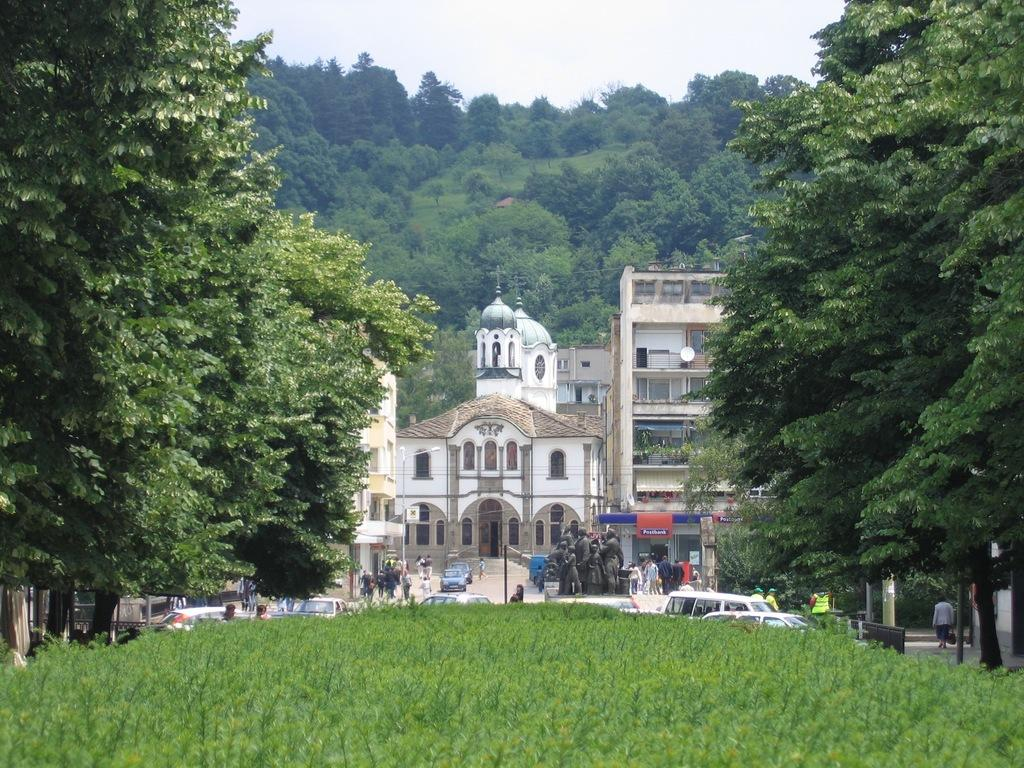What type of living organisms can be seen in the image? Plants and trees are visible in the image. What can be seen on the path in the image? There are vehicles on a path in the image. What type of gathering can be observed in the image? There are groups of people in the image. What structures are visible behind the people in the image? There are buildings behind the people in the image. What additional features are present in the image? There are statues in the image. What type of natural feature is present in the image? There is a hill in the image. What is visible in the sky in the image? The sky is visible in the image. What is the value of the sun in the image? There is no mention of the sun in the image, and therefore no value can be assigned to it. What type of army is present in the image? There is no army present in the image. 